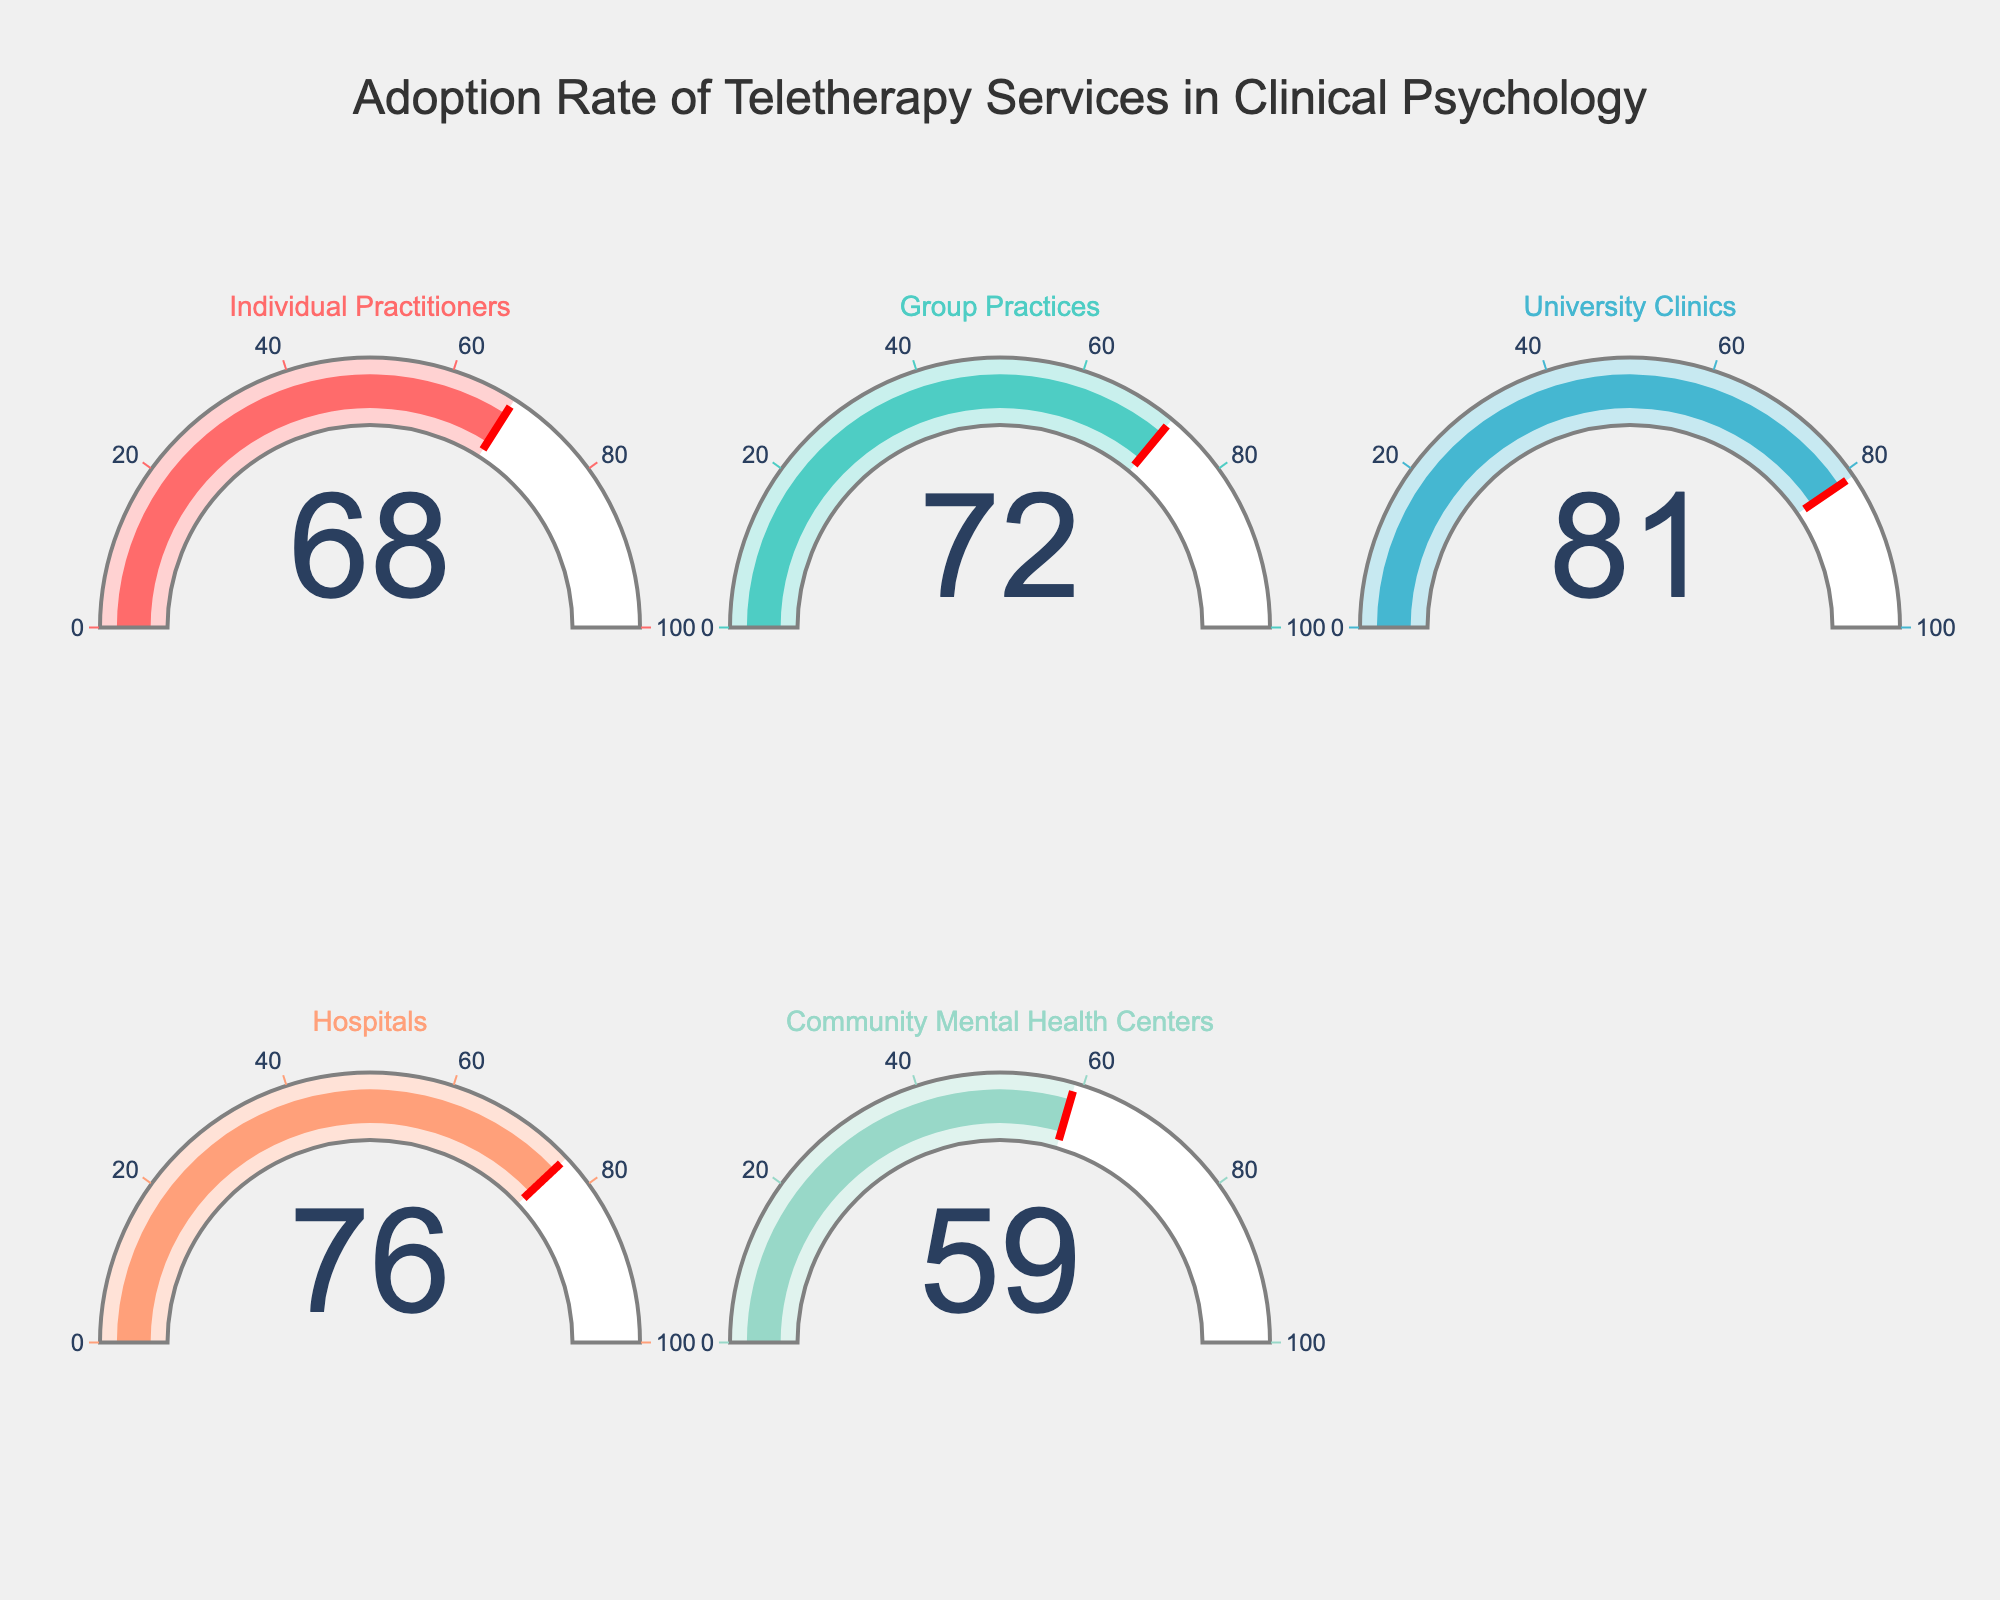What is the adoption rate for teletherapy services in Hospitals? Look at the gauge chart labeled "Hospitals" to find the displayed number.
Answer: 76 What is the average adoption rate of teletherapy services across all listed categories? Add up the adoption rates for all categories and divide by the number of categories: (68+72+81+76+59)/5 = 71.2
Answer: 71.2 Which category has the lowest adoption rate for teletherapy services? Look at each gauge's value and identify the lowest number, which belongs to the "Community Mental Health Centers".
Answer: Community Mental Health Centers Is the adoption rate for University Clinics higher or lower than for Individual Practitioners? Compare the values for "University Clinics" and "Individual Practitioners". The adoption rate for University Clinics (81) is higher than for Individual Practitioners (68).
Answer: Higher How much higher is the adoption rate for Group Practices compared to Community Mental Health Centers? Subtract the adoption rate of Community Mental Health Centers from that of Group Practices: 72 - 59 = 13
Answer: 13 What percentage of the listed categories have an adoption rate below 75? Count the number of categories with values below 75, which are Individual Practitioners (68), Group Practices (72), and Community Mental Health Centers (59), then divide by the total count and multiply by 100: (3/5) * 100 = 60%
Answer: 60% What is the difference in adoption rates between the category with the highest rate and the category with the lowest rate? Identify the highest (University Clinics, 81) and lowest (Community Mental Health Centers, 59), then subtract the lowest from the highest: 81 - 59 = 22
Answer: 22 Which categories have an adoption rate of 70 or higher? Check each category's adoption rate and list those equal to or greater than 70: Group Practices (72), University Clinics (81), and Hospitals (76).
Answer: Group Practices, University Clinics, Hospitals 